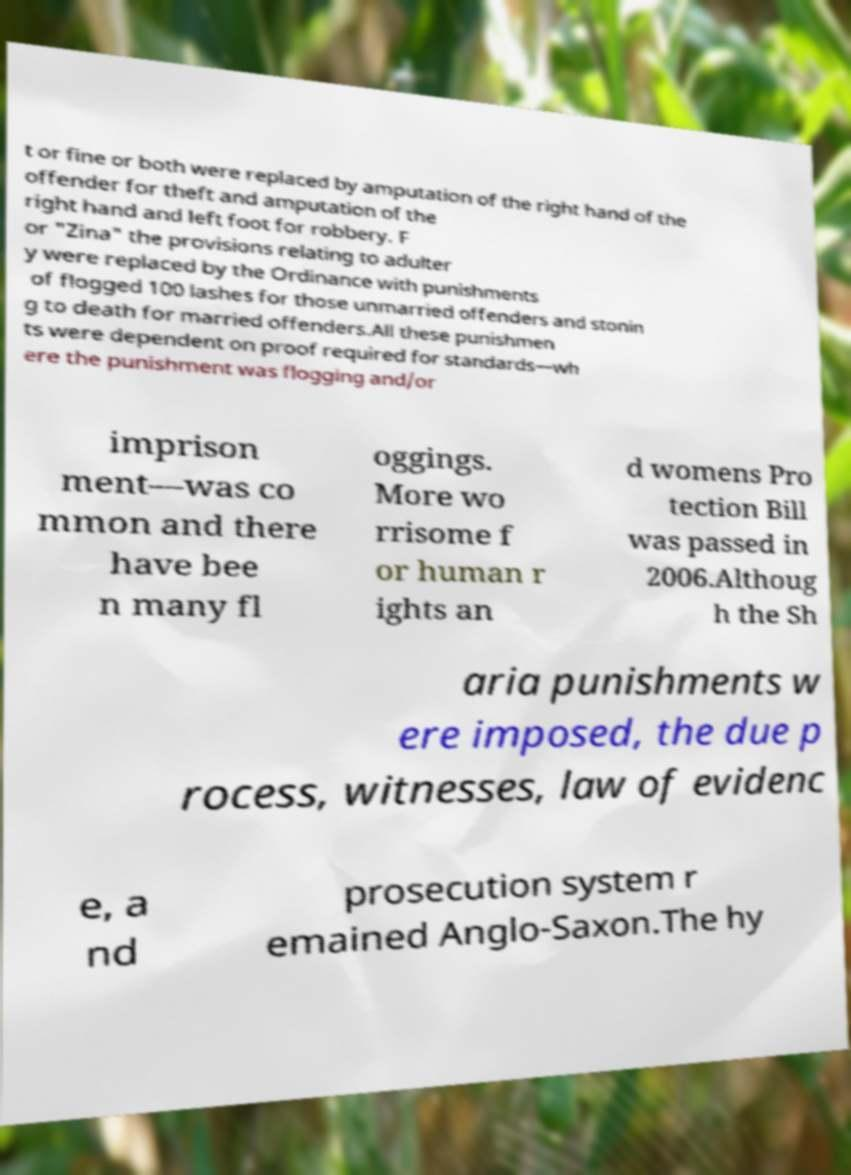There's text embedded in this image that I need extracted. Can you transcribe it verbatim? t or fine or both were replaced by amputation of the right hand of the offender for theft and amputation of the right hand and left foot for robbery. F or "Zina" the provisions relating to adulter y were replaced by the Ordinance with punishments of flogged 100 lashes for those unmarried offenders and stonin g to death for married offenders.All these punishmen ts were dependent on proof required for standards—wh ere the punishment was flogging and/or imprison ment—was co mmon and there have bee n many fl oggings. More wo rrisome f or human r ights an d womens Pro tection Bill was passed in 2006.Althoug h the Sh aria punishments w ere imposed, the due p rocess, witnesses, law of evidenc e, a nd prosecution system r emained Anglo-Saxon.The hy 